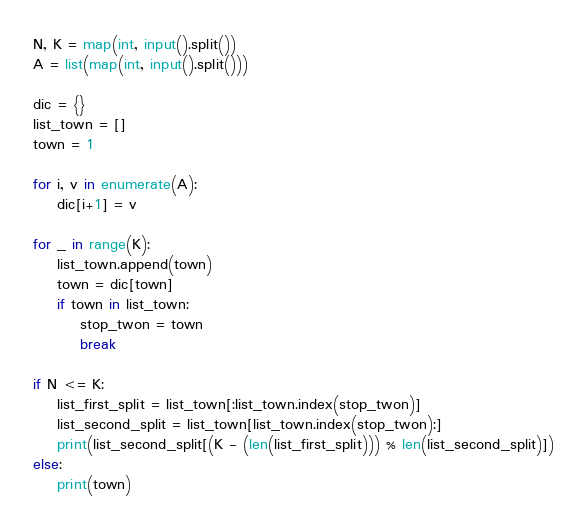Convert code to text. <code><loc_0><loc_0><loc_500><loc_500><_Python_>N, K = map(int, input().split())
A = list(map(int, input().split()))

dic = {}
list_town = []
town = 1

for i, v in enumerate(A):
    dic[i+1] = v

for _ in range(K):
    list_town.append(town)
    town = dic[town]
    if town in list_town:
        stop_twon = town
        break

if N <= K:
    list_first_split = list_town[:list_town.index(stop_twon)]
    list_second_split = list_town[list_town.index(stop_twon):]
    print(list_second_split[(K - (len(list_first_split))) % len(list_second_split)])
else:
    print(town)</code> 